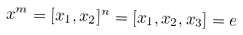<formula> <loc_0><loc_0><loc_500><loc_500>x ^ { m } = [ x _ { 1 } , x _ { 2 } ] ^ { n } = [ x _ { 1 } , x _ { 2 } , x _ { 3 } ] = e</formula> 